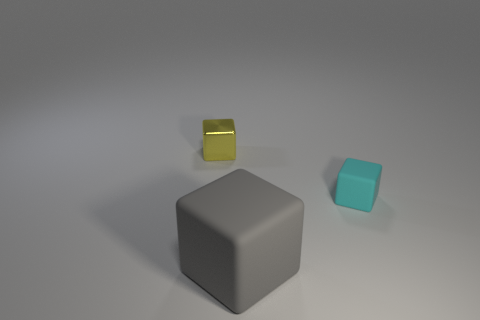Add 1 gray metallic spheres. How many objects exist? 4 Subtract 0 brown blocks. How many objects are left? 3 Subtract all small cyan matte balls. Subtract all matte objects. How many objects are left? 1 Add 2 gray matte things. How many gray matte things are left? 3 Add 2 tiny cyan cubes. How many tiny cyan cubes exist? 3 